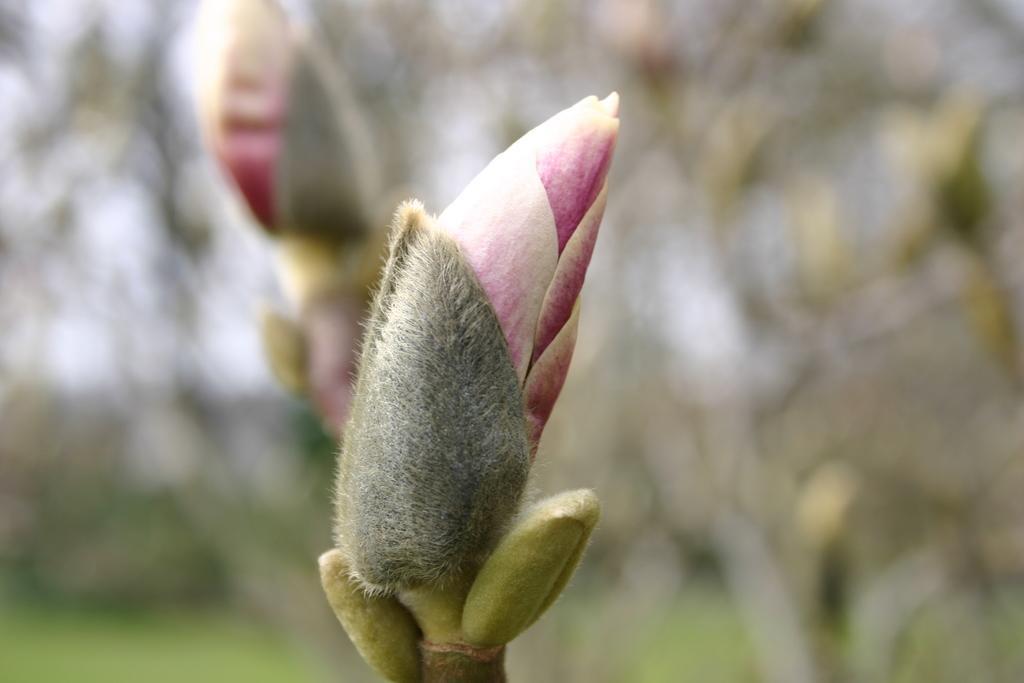In one or two sentences, can you explain what this image depicts? In this picture we can see a flower in the front, there is a blurry background. 